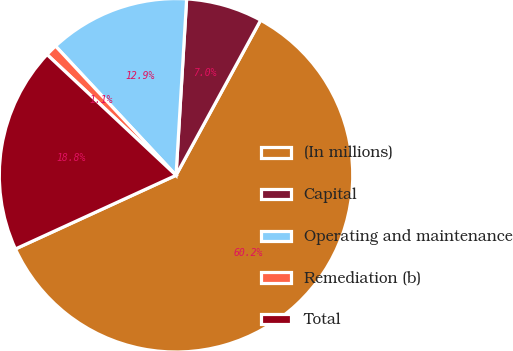<chart> <loc_0><loc_0><loc_500><loc_500><pie_chart><fcel>(In millions)<fcel>Capital<fcel>Operating and maintenance<fcel>Remediation (b)<fcel>Total<nl><fcel>60.21%<fcel>6.99%<fcel>12.9%<fcel>1.08%<fcel>18.82%<nl></chart> 